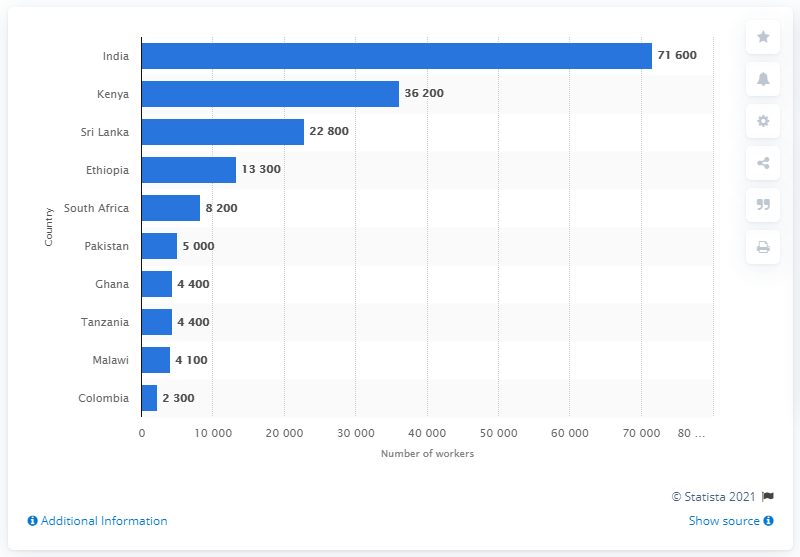Point out several critical features in this image. In 2012, approximately 71,600 workers in India were involved in Fairtrade certified activities. 